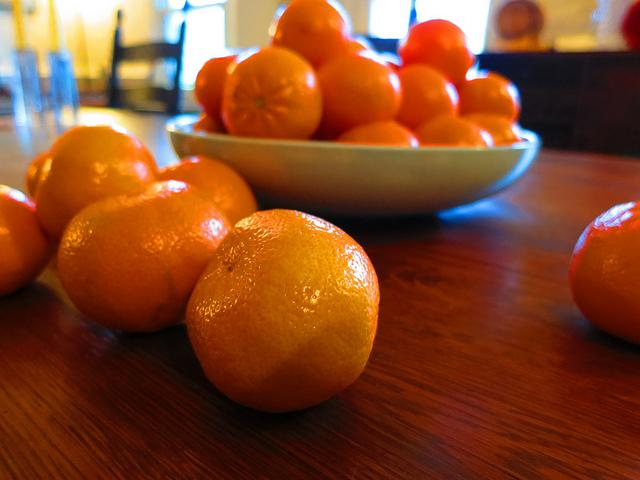What utensil is usually needed with this food?

Choices:
A) knife
B) pitchfork
C) spatula
D) chopstick knife 